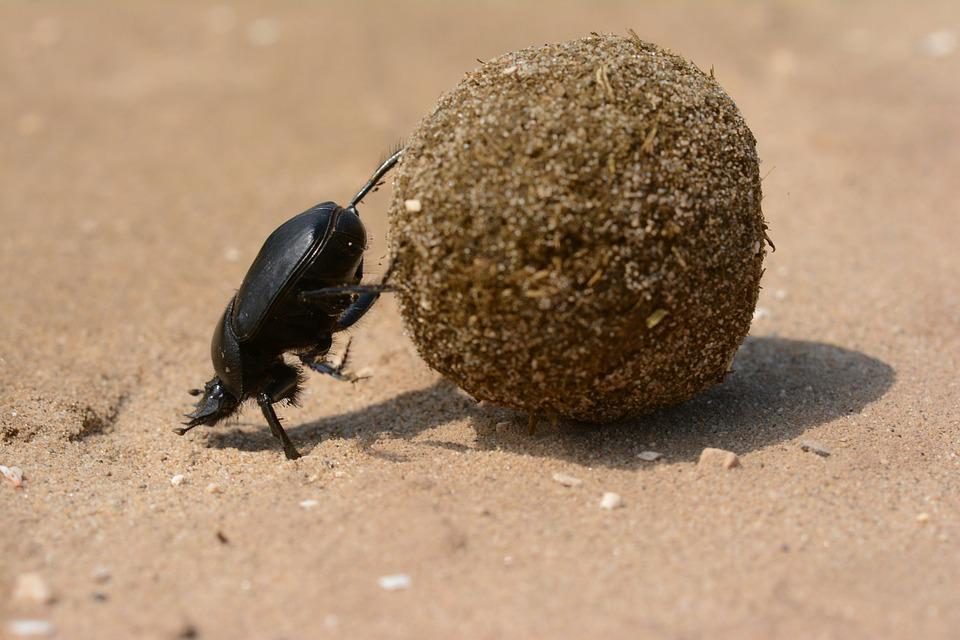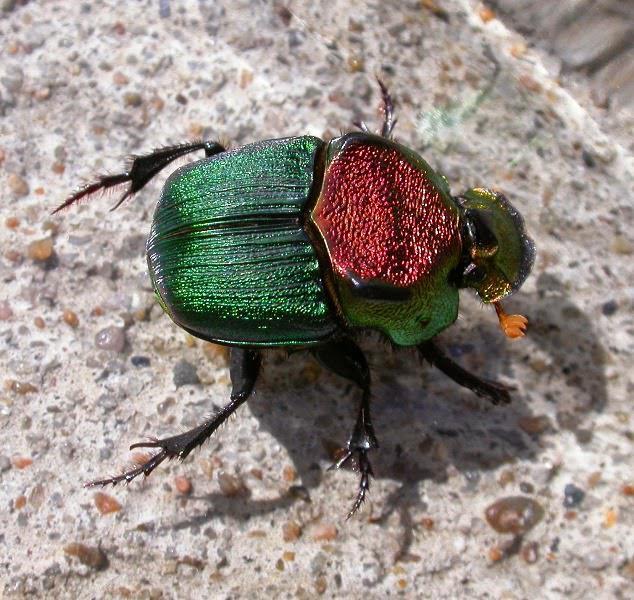The first image is the image on the left, the second image is the image on the right. Considering the images on both sides, is "An image shows a beetle without a dung ball." valid? Answer yes or no. Yes. 